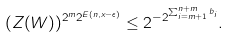Convert formula to latex. <formula><loc_0><loc_0><loc_500><loc_500>( Z ( W ) ) ^ { 2 ^ { m } 2 ^ { E ( n , x - \epsilon ) } } \leq 2 ^ { - 2 ^ { \sum _ { i = m + 1 } ^ { n + m } b _ { i } } } .</formula> 